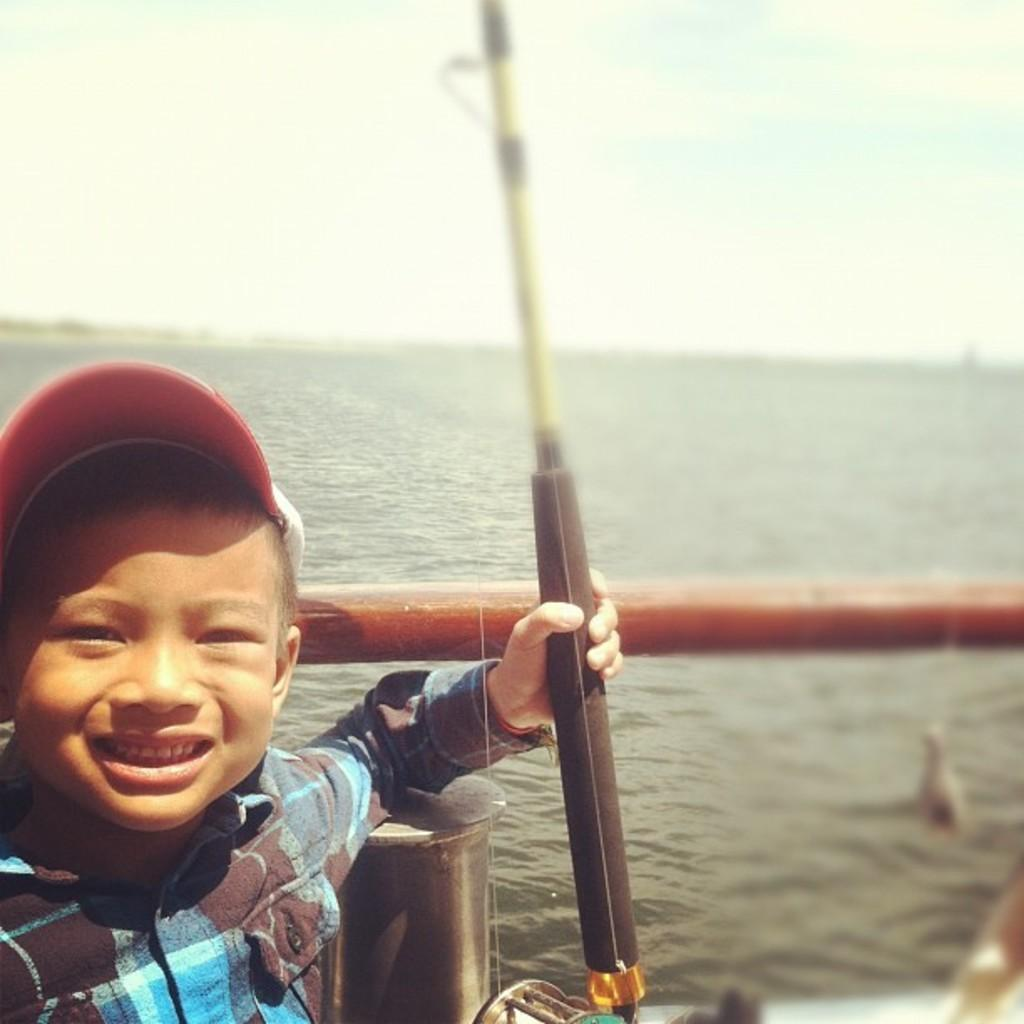Who is the main subject in the image? There is a little boy in the image. What is the boy's facial expression? The boy is smiling. What type of clothing is the boy wearing? The boy is wearing a shirt and a cap. What can be seen in the background of the image? There is water and the sky visible in the image. Can you see a snake slithering in the water in the image? There is no snake present in the image; only the little boy and the water are visible. 